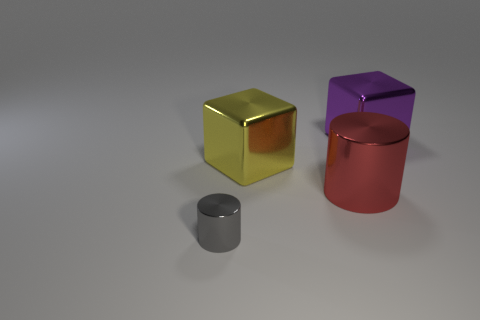What size is the yellow block?
Provide a succinct answer. Large. What is the shape of the metallic object that is behind the big red cylinder and right of the large yellow thing?
Provide a short and direct response. Cube. There is a big metallic object that is the same shape as the small gray shiny object; what color is it?
Offer a terse response. Red. How many objects are either large things that are in front of the yellow metallic object or small things that are in front of the large yellow metal object?
Make the answer very short. 2. There is a tiny gray shiny thing; what shape is it?
Provide a short and direct response. Cylinder. How many other red things are made of the same material as the small object?
Your answer should be very brief. 1. What color is the large shiny cylinder?
Offer a terse response. Red. What color is the metallic cylinder that is the same size as the purple shiny cube?
Your answer should be very brief. Red. Is the shape of the gray object left of the big purple thing the same as the large metal object that is in front of the big yellow metallic block?
Offer a very short reply. Yes. What number of other objects are there of the same size as the purple thing?
Your answer should be very brief. 2. 